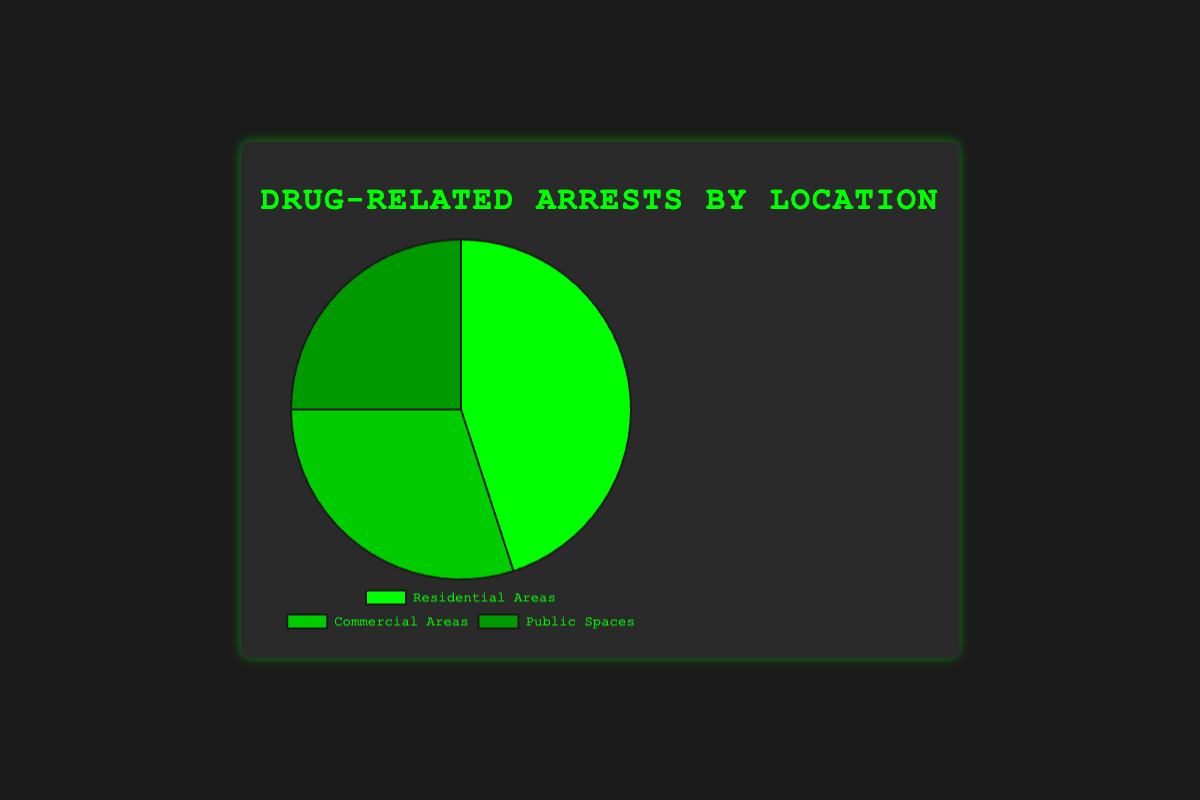What percentage of drug-related arrests happen in Residential Areas? The chart shows that 45% of drug-related arrests occur in Residential Areas.
Answer: 45% Which location has the highest percentage of drug-related arrests? By looking at the chart, Residential Areas have the highest percentage with 45%.
Answer: Residential Areas Compare the percentage of arrests in Commercial Areas to Public Spaces. Which has more? The chart shows 30% for Commercial Areas and 25% for Public Spaces. Commercial Areas have a higher percentage.
Answer: Commercial Areas What is the total percentage of arrests that happen in Commercial Areas and Public Spaces combined? Adding the percentages from the chart: 30% (Commercial Areas) + 25% (Public Spaces) = 55%.
Answer: 55% How much higher is the percentage of drug-related arrests in Residential Areas compared to Public Spaces? Subtract the percentage for Public Spaces from Residential Areas: 45% - 25% = 20%.
Answer: 20% What color represents the arrests in Public Spaces on the chart? The chart uses a color scheme where Public Spaces are represented by a color distinct from the other segments. Visually, Public Spaces are in a darker green shade compared to the other sections.
Answer: Dark Green If you combine the percentages of Residential and Commercial Areas, is their total more or less than 70%? Adding the percentages: 45% (Residential) + 30% (Commercial) = 75%, which is more than 70%.
Answer: More Which location has the smallest percentage of arrests? The chart shows that Public Spaces have the smallest percentage with 25%.
Answer: Public Spaces What is the difference in the percentage of arrests between Residential and Commercial Areas? Subtract the percentage of Commercial Areas from Residential Areas: 45% - 30% = 15%.
Answer: 15% Of the three locations, which two have the closest percentages of drug-related arrests? Comparing the percentages: Residential (45%), Commercial (30%), Public Spaces (25%). The smallest difference is between Commercial Areas and Public Spaces: 30% - 25% = 5%.
Answer: Commercial Areas and Public Spaces 